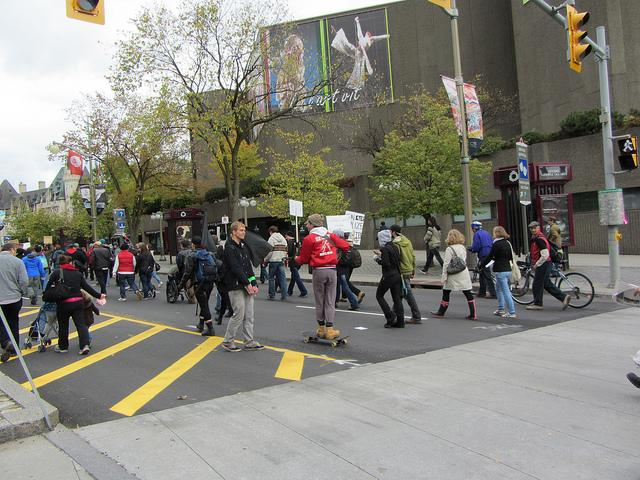What type of area is shown?

Choices:
A) public
B) rural
C) residential
D) private public 